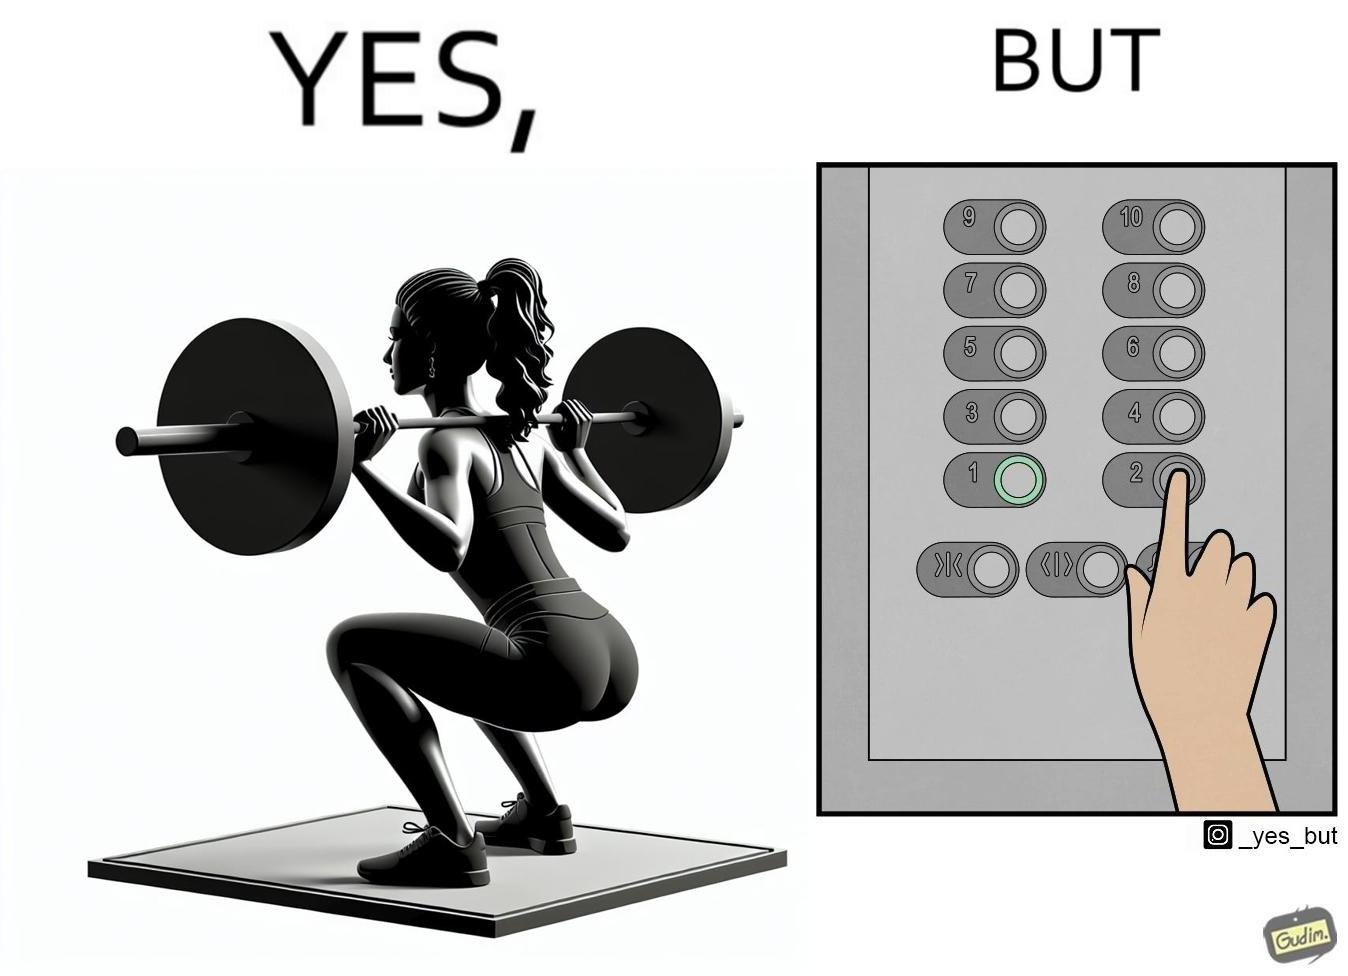Describe what you see in this image. The image is satirical because it shows that while people do various kinds of exercises and go to gym to stay fit, they avoid doing simplest of physical tasks like using stairs instead of elevators to get to even the first or the second floor of a building. 